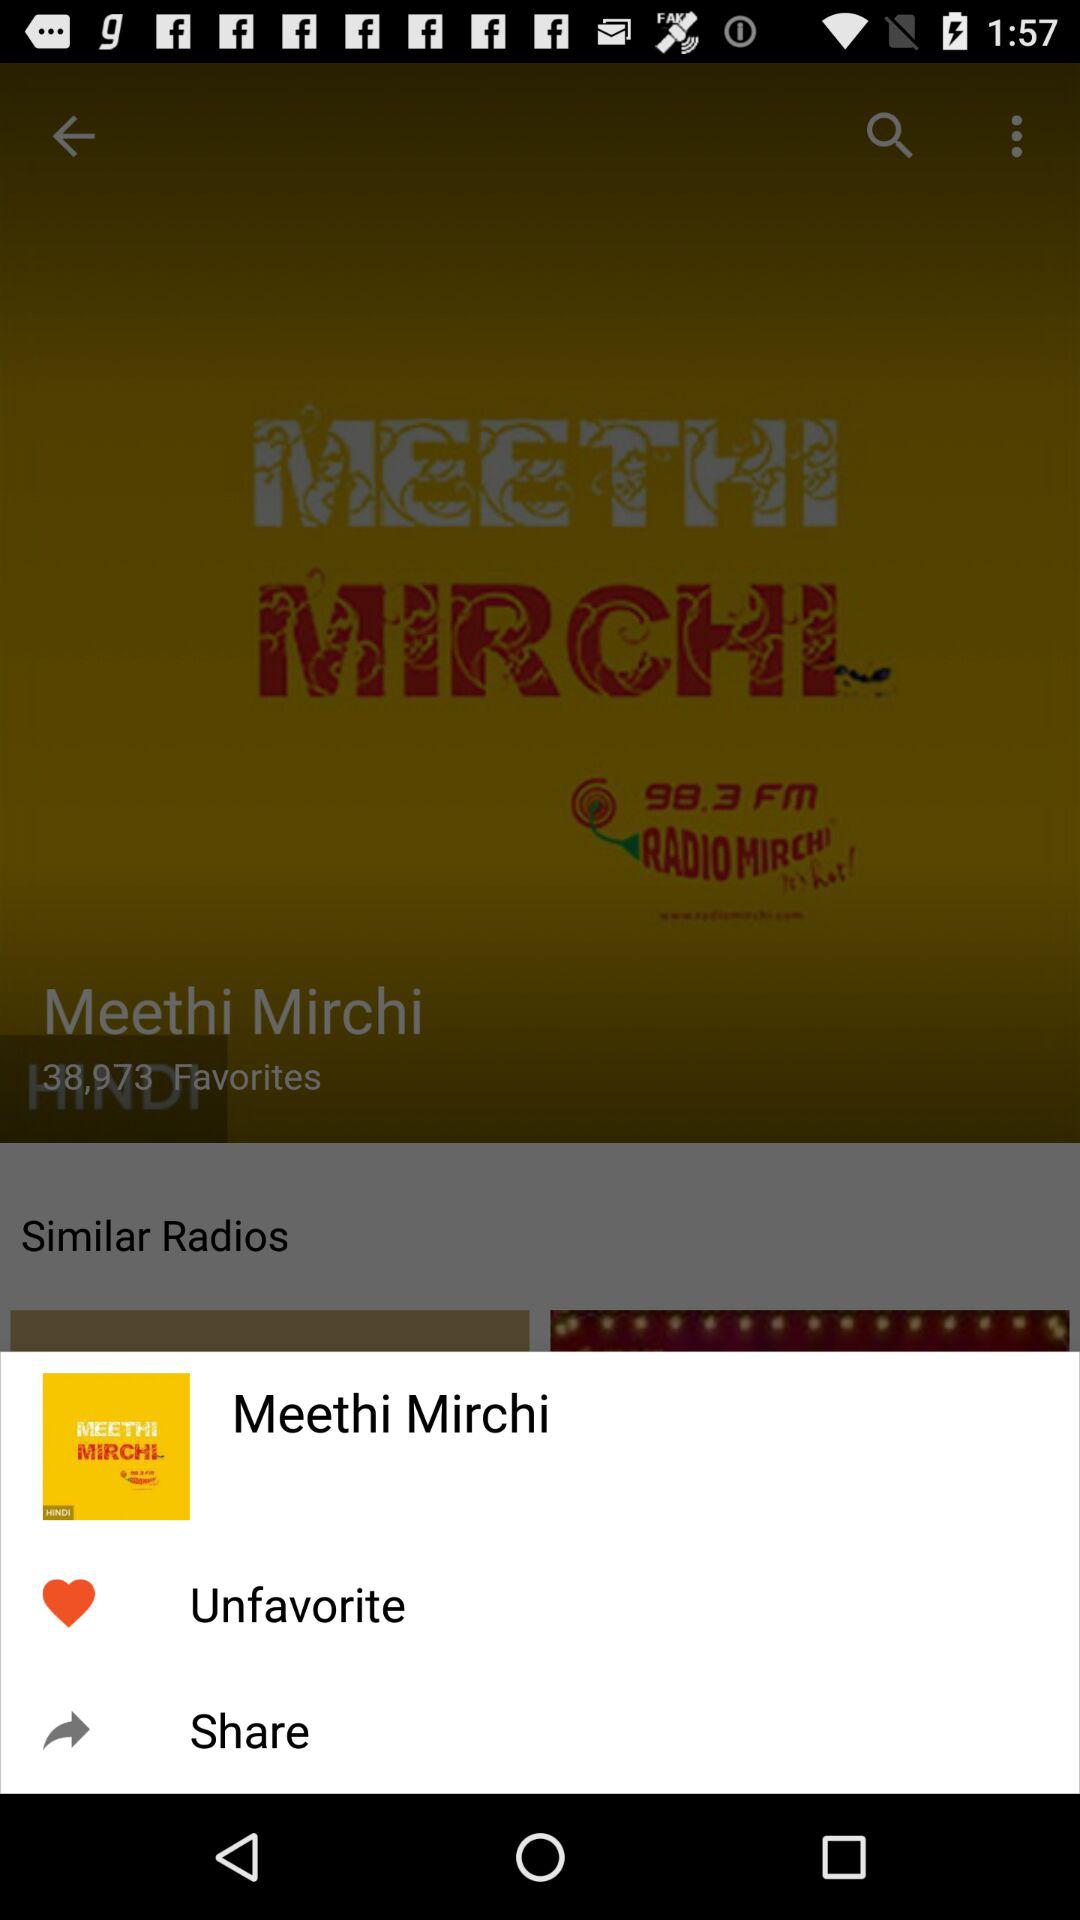With which applications can this be shared?
When the provided information is insufficient, respond with <no answer>. <no answer> 